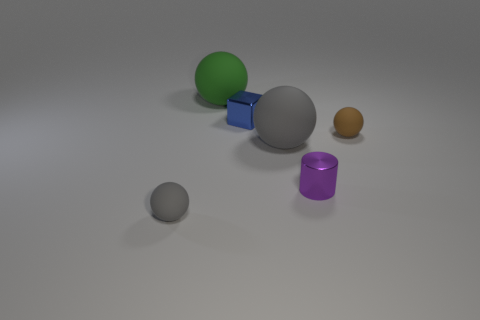Is the number of big yellow rubber things less than the number of blue cubes?
Provide a short and direct response. Yes. The small gray object that is made of the same material as the green thing is what shape?
Keep it short and to the point. Sphere. How many tiny spheres are on the left side of the green rubber thing behind the big ball that is in front of the green rubber object?
Your response must be concise. 1. There is a rubber thing that is right of the large green sphere and on the left side of the brown thing; what is its shape?
Keep it short and to the point. Sphere. Is the number of tiny purple things that are behind the metallic cube less than the number of brown metal objects?
Your answer should be very brief. No. How many large things are gray balls or purple metallic balls?
Your answer should be very brief. 1. What size is the metal cylinder?
Provide a succinct answer. Small. Is there any other thing that has the same material as the blue block?
Ensure brevity in your answer.  Yes. How many rubber spheres are to the left of the purple metallic cylinder?
Make the answer very short. 3. What is the size of the green rubber object that is the same shape as the brown object?
Make the answer very short. Large. 